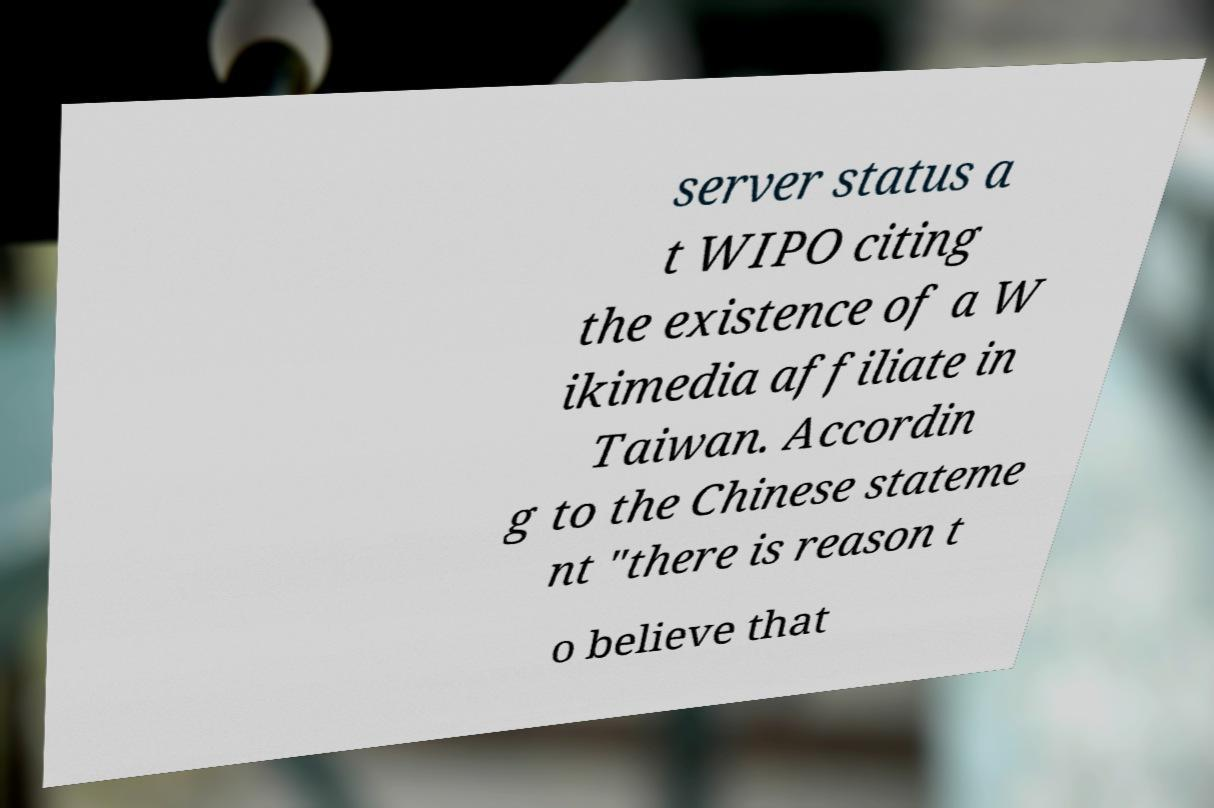Could you assist in decoding the text presented in this image and type it out clearly? server status a t WIPO citing the existence of a W ikimedia affiliate in Taiwan. Accordin g to the Chinese stateme nt "there is reason t o believe that 